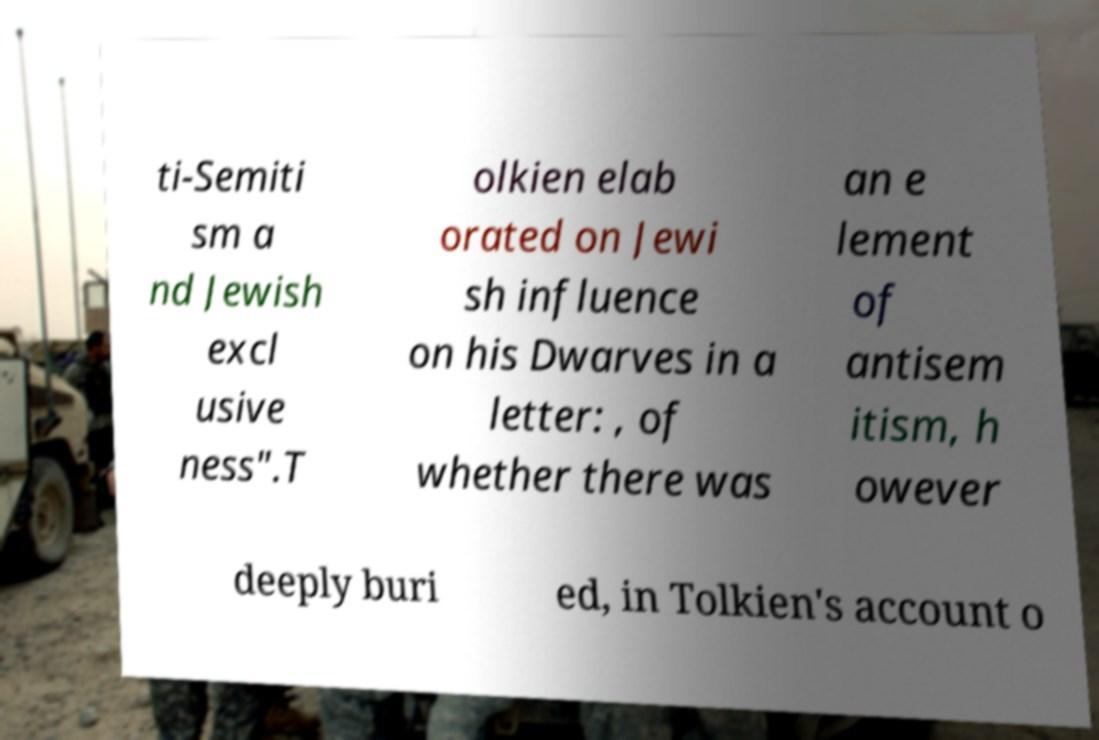There's text embedded in this image that I need extracted. Can you transcribe it verbatim? ti-Semiti sm a nd Jewish excl usive ness".T olkien elab orated on Jewi sh influence on his Dwarves in a letter: , of whether there was an e lement of antisem itism, h owever deeply buri ed, in Tolkien's account o 